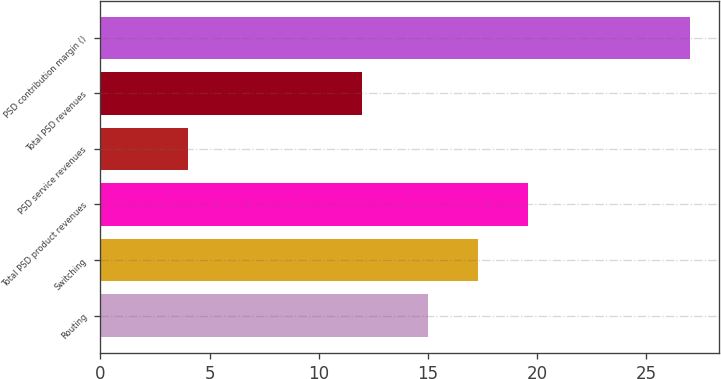Convert chart. <chart><loc_0><loc_0><loc_500><loc_500><bar_chart><fcel>Routing<fcel>Switching<fcel>Total PSD product revenues<fcel>PSD service revenues<fcel>Total PSD revenues<fcel>PSD contribution margin ()<nl><fcel>15<fcel>17.3<fcel>19.6<fcel>4<fcel>12<fcel>27<nl></chart> 